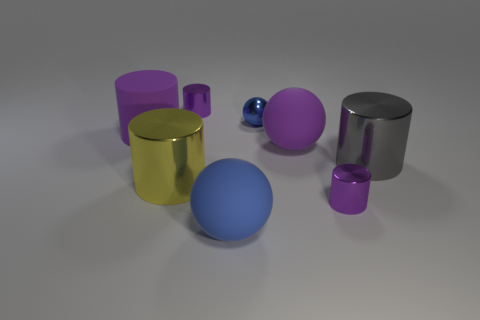There is a big purple thing that is on the left side of the purple matte ball; what material is it?
Ensure brevity in your answer.  Rubber. How many things are either blue matte balls in front of the large yellow object or tiny blue things?
Your response must be concise. 2. Is the number of blue balls to the left of the blue rubber ball the same as the number of brown rubber cubes?
Your answer should be compact. Yes. Do the gray metallic cylinder and the purple matte sphere have the same size?
Your answer should be compact. Yes. There is a rubber cylinder that is the same size as the gray object; what is its color?
Your answer should be compact. Purple. There is a yellow metallic cylinder; does it have the same size as the rubber thing on the right side of the big blue sphere?
Ensure brevity in your answer.  Yes. What number of big shiny cylinders are the same color as the rubber cylinder?
Make the answer very short. 0. What number of things are large green blocks or purple metal cylinders on the left side of the small blue object?
Offer a terse response. 1. There is a purple shiny thing that is left of the blue rubber ball; is its size the same as the purple cylinder that is in front of the large yellow cylinder?
Your answer should be compact. Yes. Is there a blue thing that has the same material as the purple sphere?
Your response must be concise. Yes. 